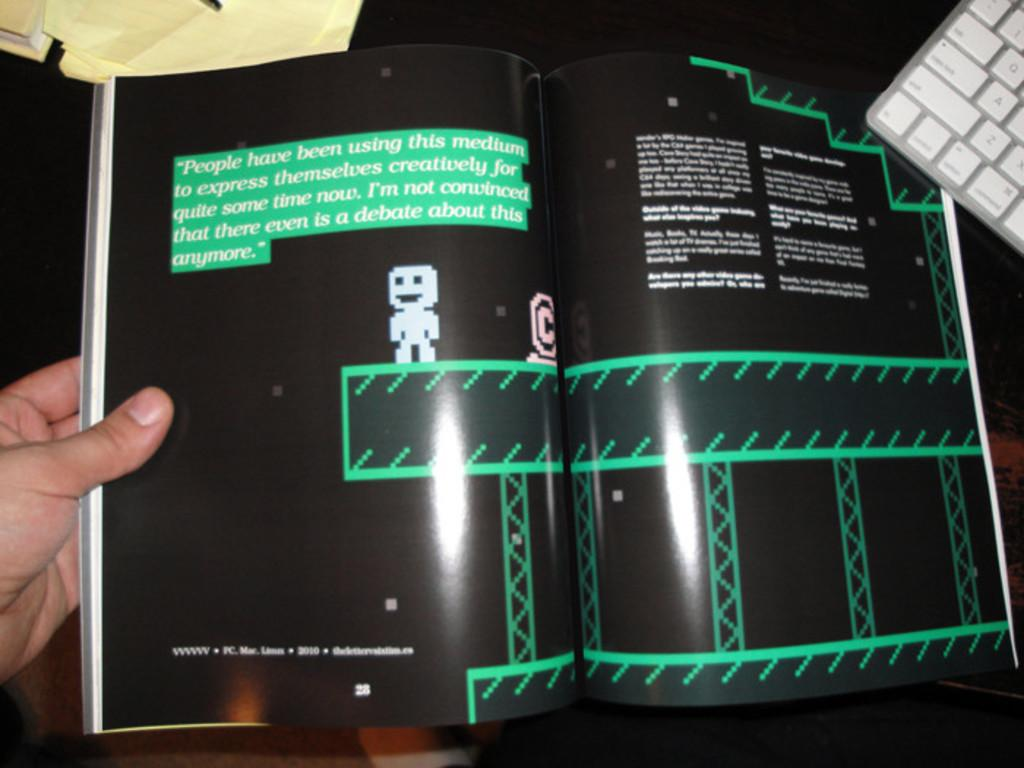<image>
Summarize the visual content of the image. Two black pages in a book have a highlighted paragraph talking about how to express themselves. 